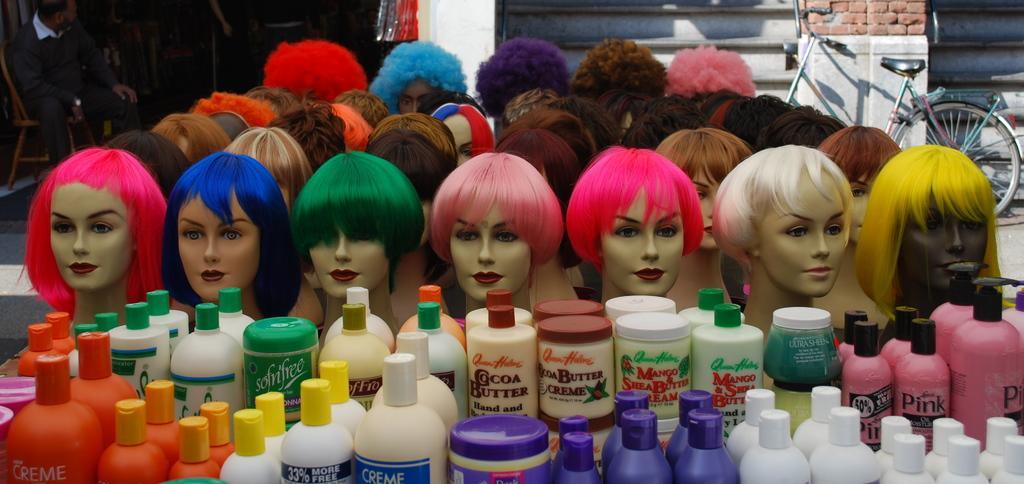In one or two sentences, can you explain what this image depicts? In this image we can see mannequins with different colored wigs. At the bottom there are cosmetics. On the right we can see a bicycle. On the left there is a man sitting. In the background there is a wall and we can see a person. 